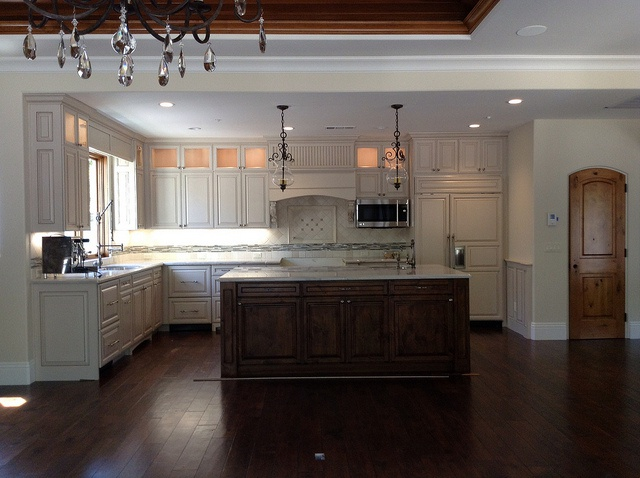Describe the objects in this image and their specific colors. I can see microwave in gray and black tones, sink in gray, black, and darkgray tones, and sink in gray, darkgray, lavender, and lightgray tones in this image. 